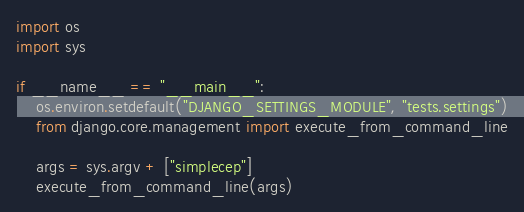<code> <loc_0><loc_0><loc_500><loc_500><_Python_>import os
import sys

if __name__ == "__main__":
    os.environ.setdefault("DJANGO_SETTINGS_MODULE", "tests.settings")
    from django.core.management import execute_from_command_line

    args = sys.argv + ["simplecep"]
    execute_from_command_line(args)
</code> 